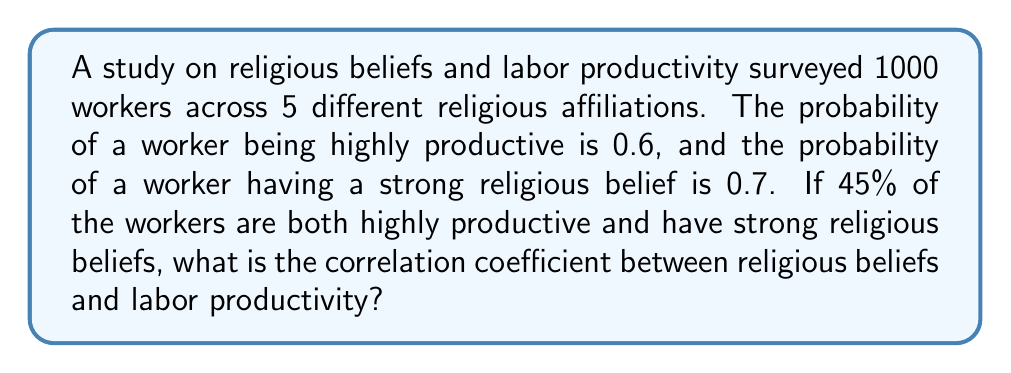Can you solve this math problem? To solve this problem, we'll use the correlation coefficient formula for binary variables:

$$ r = \frac{p_{11} - p_1p_2}{\sqrt{p_1(1-p_1)p_2(1-p_2)}} $$

Where:
$p_{11}$ = probability of both events occurring
$p_1$ = probability of the first event (high productivity)
$p_2$ = probability of the second event (strong religious belief)

Given:
$p_1 = 0.6$ (probability of high productivity)
$p_2 = 0.7$ (probability of strong religious belief)
$p_{11} = 0.45$ (probability of both high productivity and strong religious belief)

Step 1: Calculate the numerator
$p_{11} - p_1p_2 = 0.45 - (0.6 \times 0.7) = 0.45 - 0.42 = 0.03$

Step 2: Calculate the denominator
$\sqrt{p_1(1-p_1)p_2(1-p_2)} = \sqrt{0.6(1-0.6)0.7(1-0.7)}$
$= \sqrt{0.6 \times 0.4 \times 0.7 \times 0.3} = \sqrt{0.0504} \approx 0.2245$

Step 3: Calculate the correlation coefficient
$r = \frac{0.03}{0.2245} \approx 0.1336$

Therefore, the correlation coefficient between religious beliefs and labor productivity is approximately 0.1336.
Answer: 0.1336 